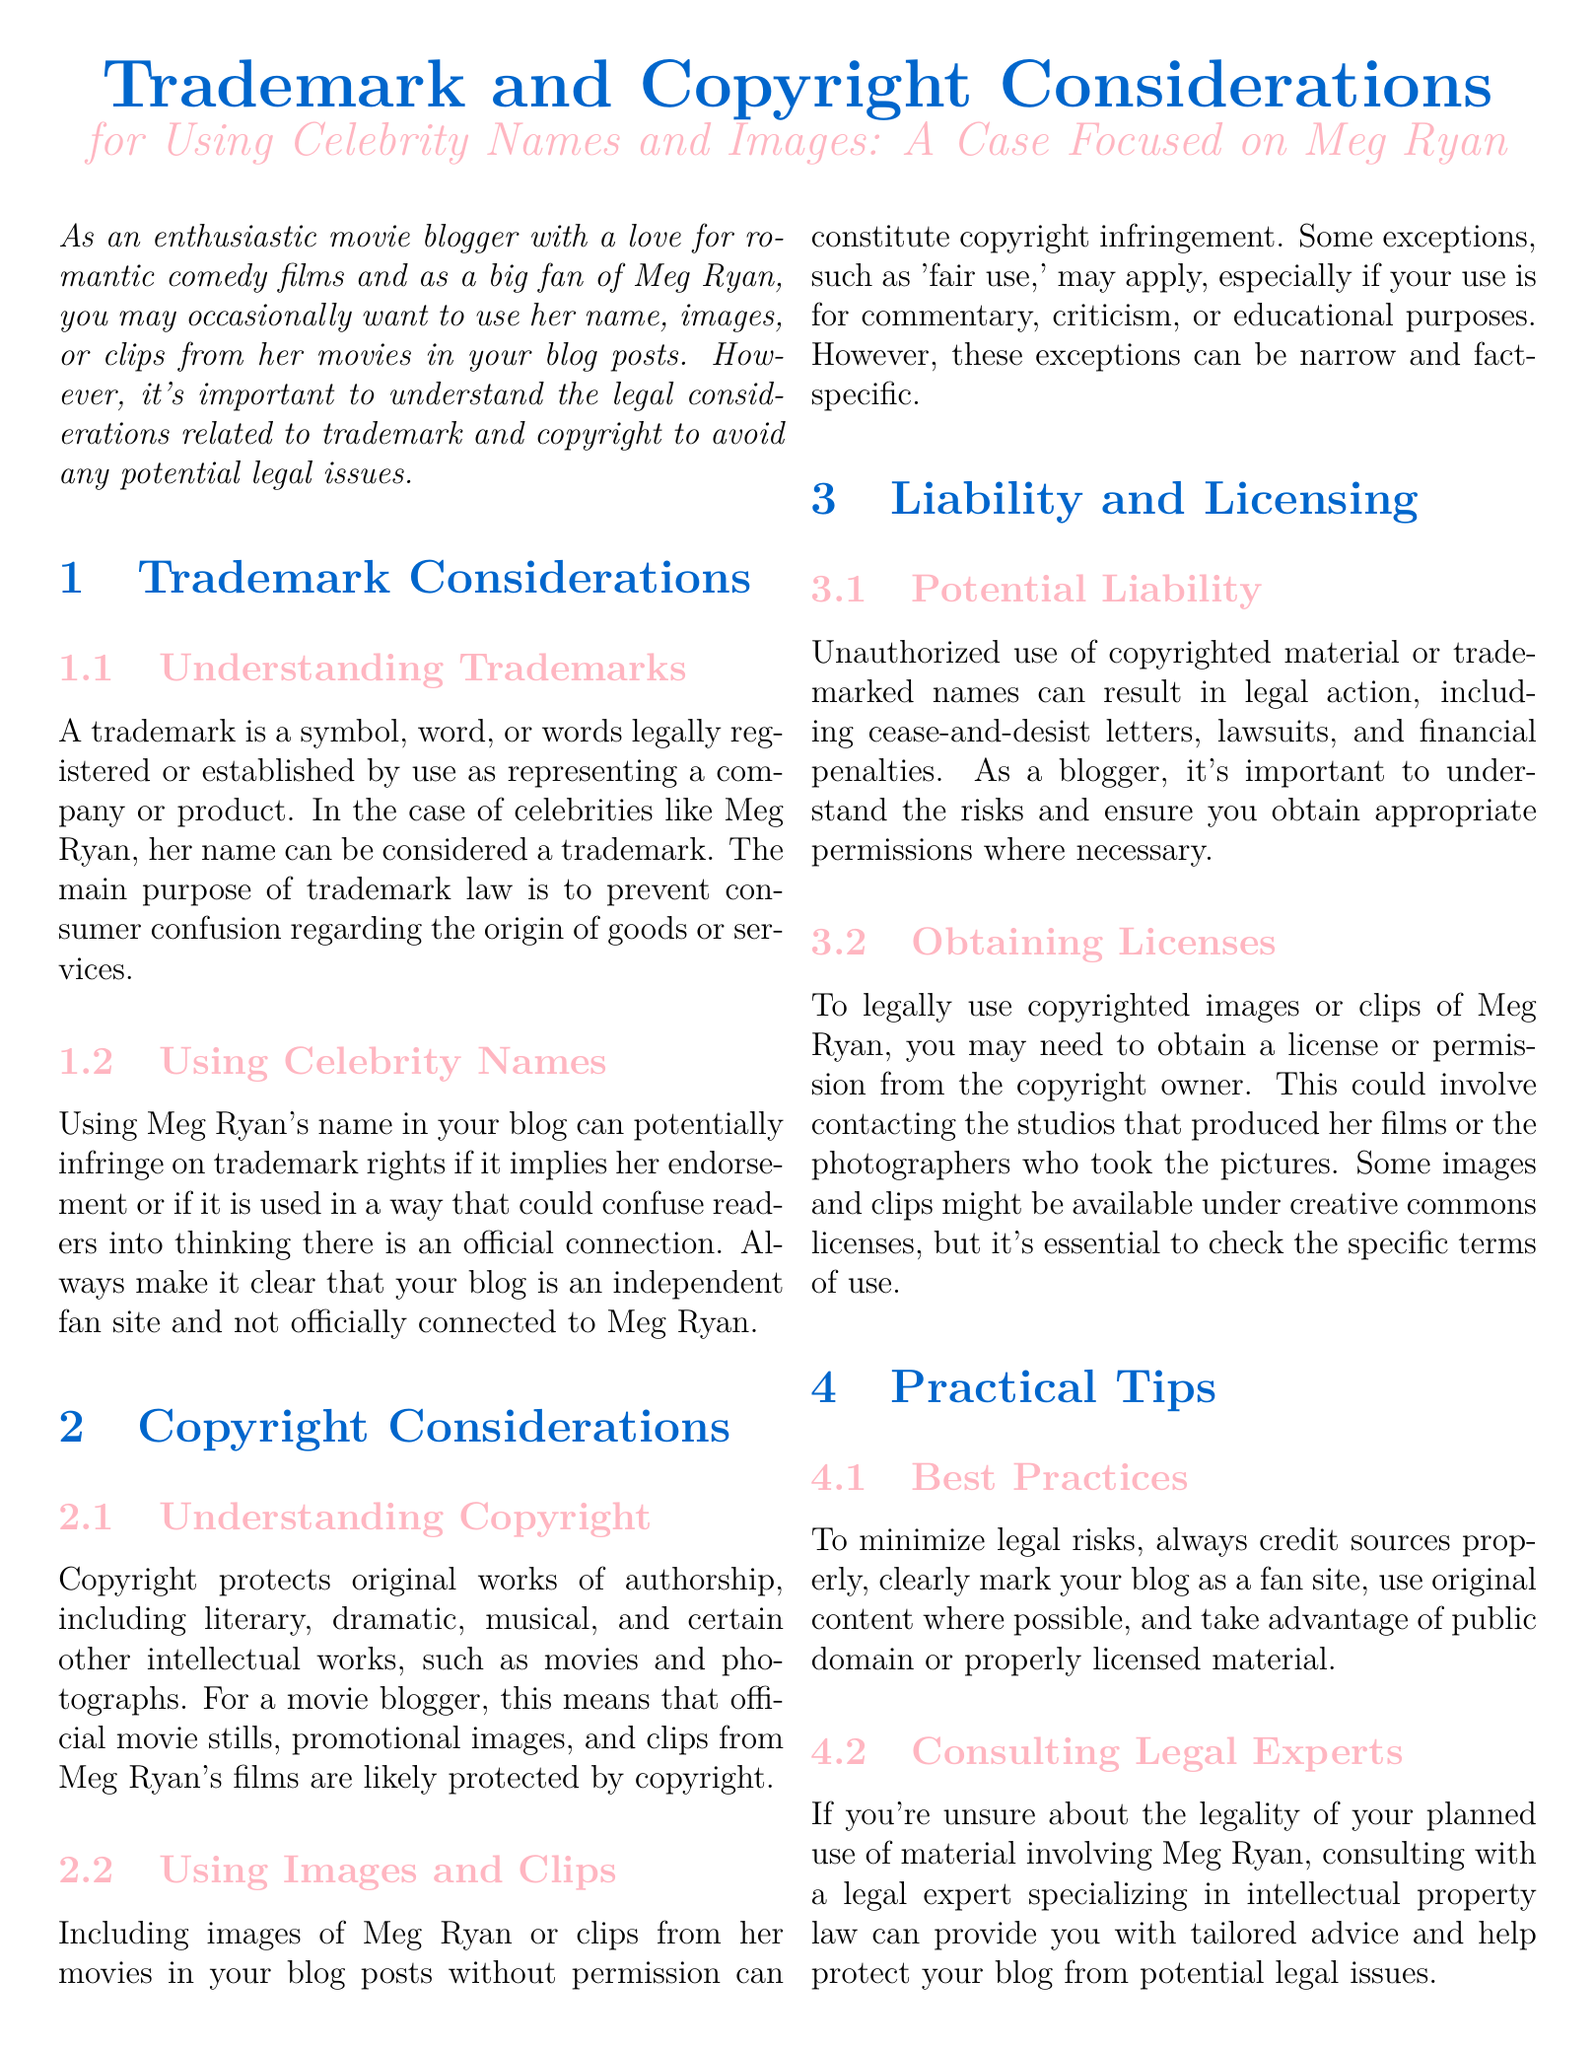What is the purpose of trademark law? The main purpose of trademark law is to prevent consumer confusion regarding the origin of goods or services.
Answer: Prevent consumer confusion What is considered when using Meg Ryan's name? Using Meg Ryan's name can potentially infringe on trademark rights if it implies her endorsement or could confuse readers.
Answer: Infringe on trademark rights Which works does copyright protect? Copyright protects original works of authorship, including literary, dramatic, musical, and certain other intellectual works, such as movies and photographs.
Answer: Original works of authorship What can unauthorized use of copyrighted material result in? Unauthorized use can result in legal action, including cease-and-desist letters, lawsuits, and financial penalties.
Answer: Legal action What do you need to obtain to legally use copyrighted images of Meg Ryan? You may need to obtain a license or permission from the copyright owner.
Answer: License or permission What are some best practices to minimize legal risks? Best practices include crediting sources properly, marking your blog as a fan site, using original content, and utilizing public domain materials.
Answer: Crediting sources properly What should you do if unsure about the legality of your material usage? Consulting with a legal expert specializing in intellectual property law can provide tailored advice.
Answer: Consult a legal expert 